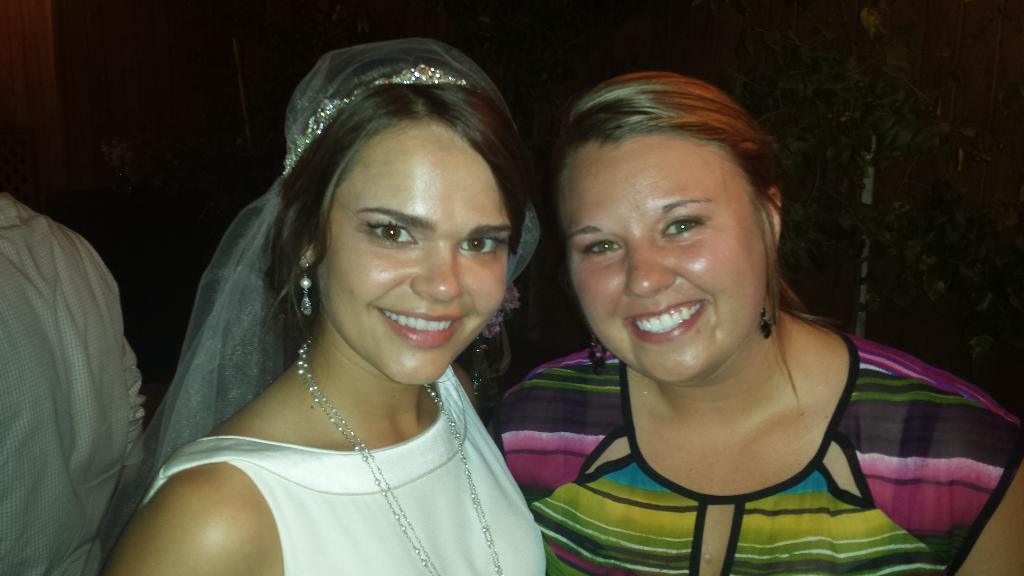Please provide a concise description of this image. In this picture we can see two women smiling and beside them we can see a person, leaves and in the background it is dark. 